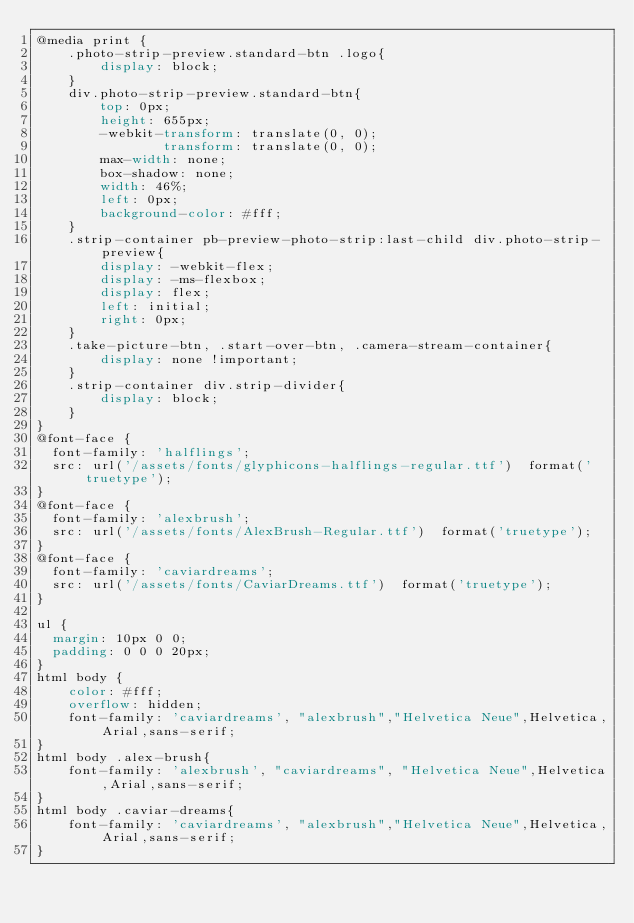Convert code to text. <code><loc_0><loc_0><loc_500><loc_500><_CSS_>@media print {
    .photo-strip-preview.standard-btn .logo{
        display: block;
    }
    div.photo-strip-preview.standard-btn{
        top: 0px;
        height: 655px;
        -webkit-transform: translate(0, 0);
                transform: translate(0, 0);
        max-width: none;
        box-shadow: none;
        width: 46%;
        left: 0px;
        background-color: #fff;
    }
    .strip-container pb-preview-photo-strip:last-child div.photo-strip-preview{
        display: -webkit-flex;
        display: -ms-flexbox;
        display: flex;
        left: initial;
        right: 0px;
    }
    .take-picture-btn, .start-over-btn, .camera-stream-container{
        display: none !important;
    }
    .strip-container div.strip-divider{
        display: block;
    }
}
@font-face {
  font-family: 'halflings';
  src: url('/assets/fonts/glyphicons-halflings-regular.ttf')  format('truetype');
}
@font-face {
  font-family: 'alexbrush';
  src: url('/assets/fonts/AlexBrush-Regular.ttf')  format('truetype');
}
@font-face {
  font-family: 'caviardreams';
  src: url('/assets/fonts/CaviarDreams.ttf')  format('truetype');
}

ul {
  margin: 10px 0 0;
  padding: 0 0 0 20px;
}
html body {
    color: #fff;
    overflow: hidden;
    font-family: 'caviardreams', "alexbrush","Helvetica Neue",Helvetica,Arial,sans-serif;
}
html body .alex-brush{
    font-family: 'alexbrush', "caviardreams", "Helvetica Neue",Helvetica,Arial,sans-serif;
}
html body .caviar-dreams{
    font-family: 'caviardreams', "alexbrush","Helvetica Neue",Helvetica,Arial,sans-serif;
}</code> 